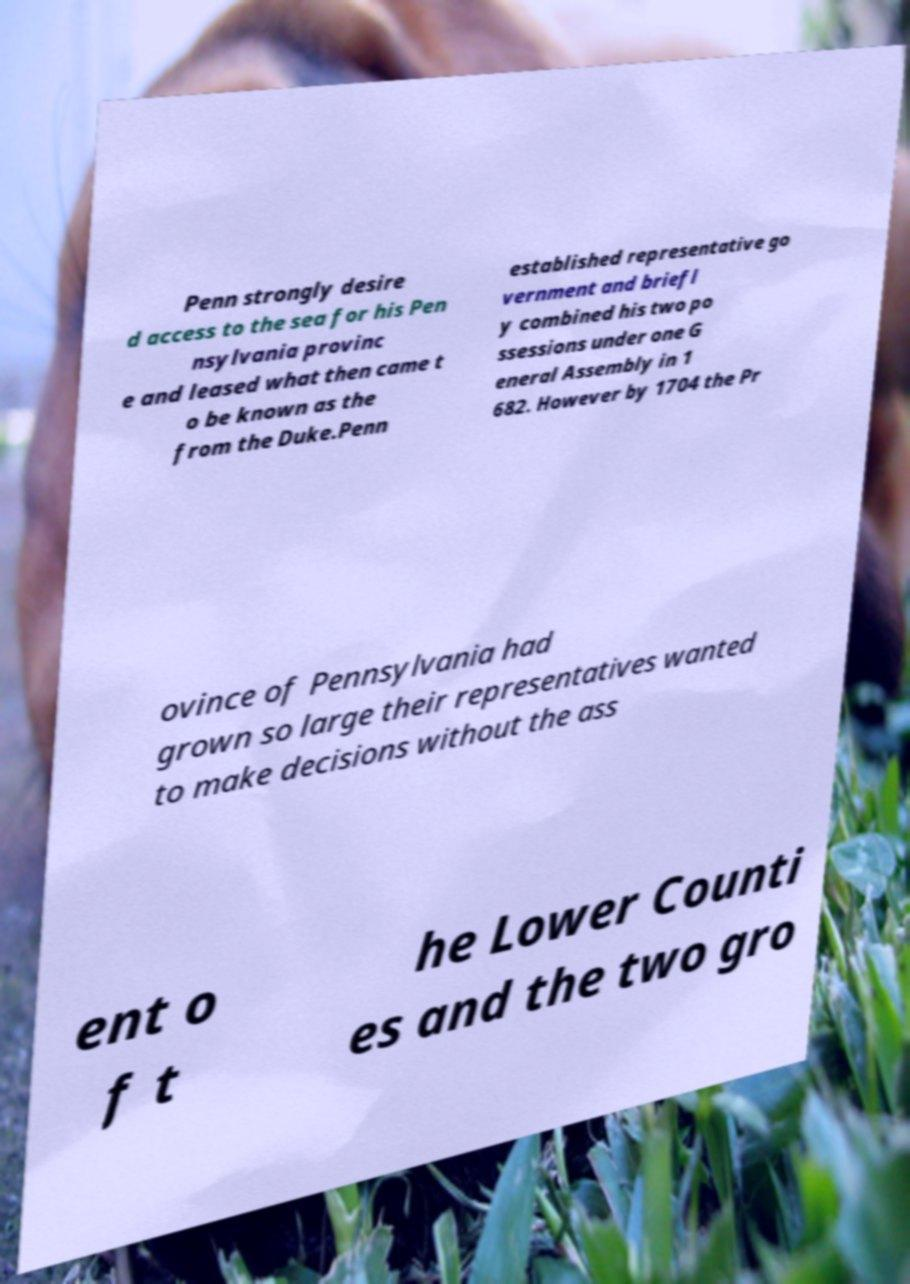Please identify and transcribe the text found in this image. Penn strongly desire d access to the sea for his Pen nsylvania provinc e and leased what then came t o be known as the from the Duke.Penn established representative go vernment and briefl y combined his two po ssessions under one G eneral Assembly in 1 682. However by 1704 the Pr ovince of Pennsylvania had grown so large their representatives wanted to make decisions without the ass ent o f t he Lower Counti es and the two gro 